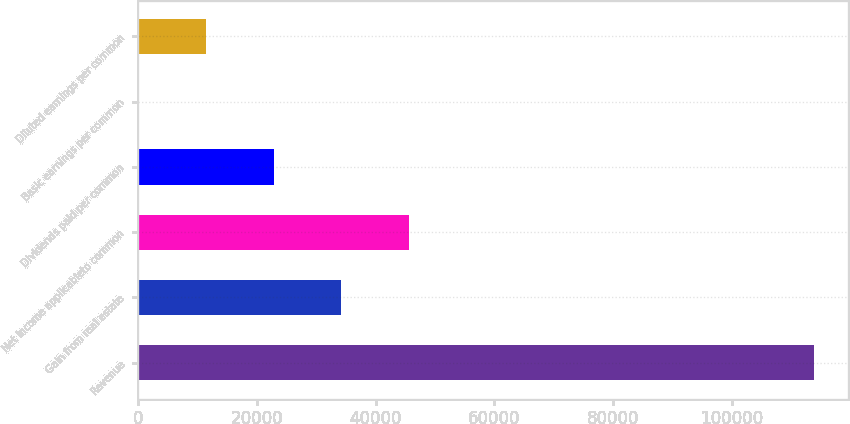<chart> <loc_0><loc_0><loc_500><loc_500><bar_chart><fcel>Revenue<fcel>Gain from real estate<fcel>Net income applicableto common<fcel>Dividends paid per common<fcel>Basic earnings per common<fcel>Diluted earnings per common<nl><fcel>113839<fcel>34151.9<fcel>45535.8<fcel>22768<fcel>0.27<fcel>11384.1<nl></chart> 